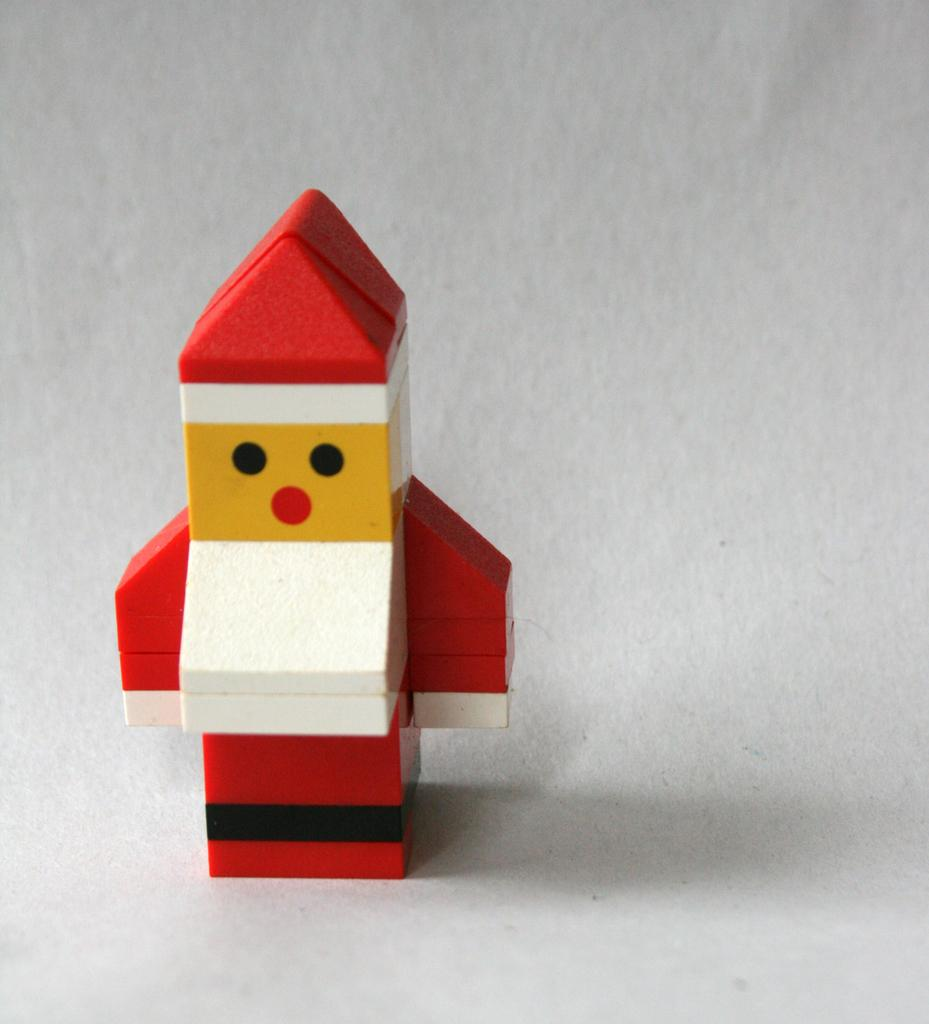What object is the main focus of the image? There is a toy in the image. What color is the background of the image? The background of the image is white. What type of credit can be seen on the toy in the image? There is no credit visible on the toy in the image. Is there a chair in the image? There is no mention of a chair in the provided facts, so we cannot definitively say if one is present or not. 